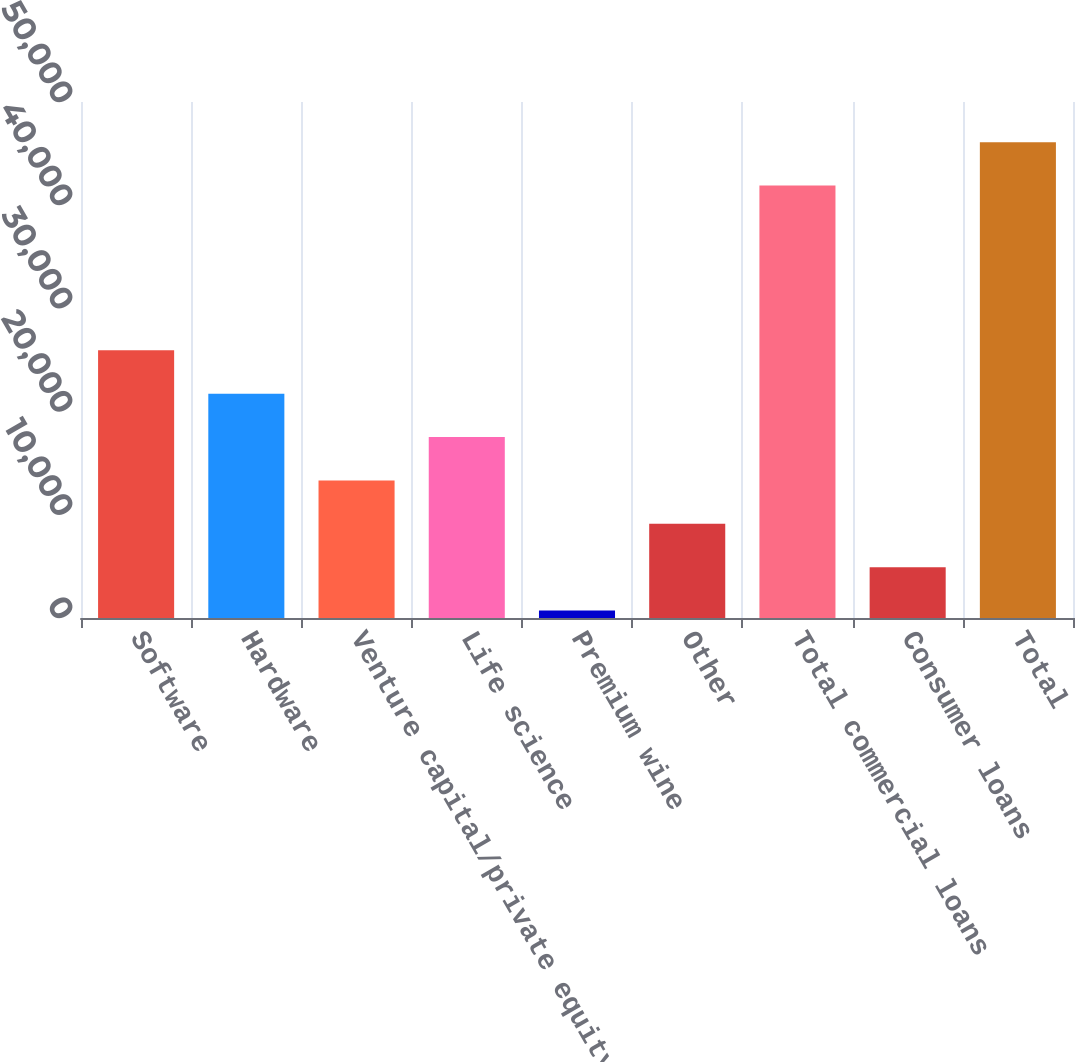<chart> <loc_0><loc_0><loc_500><loc_500><bar_chart><fcel>Software<fcel>Hardware<fcel>Venture capital/private equity<fcel>Life science<fcel>Premium wine<fcel>Other<fcel>Total commercial loans<fcel>Consumer loans<fcel>Total<nl><fcel>25937.8<fcel>21735.5<fcel>13330.9<fcel>17533.2<fcel>724<fcel>9128.6<fcel>41908<fcel>4926.3<fcel>46110.3<nl></chart> 